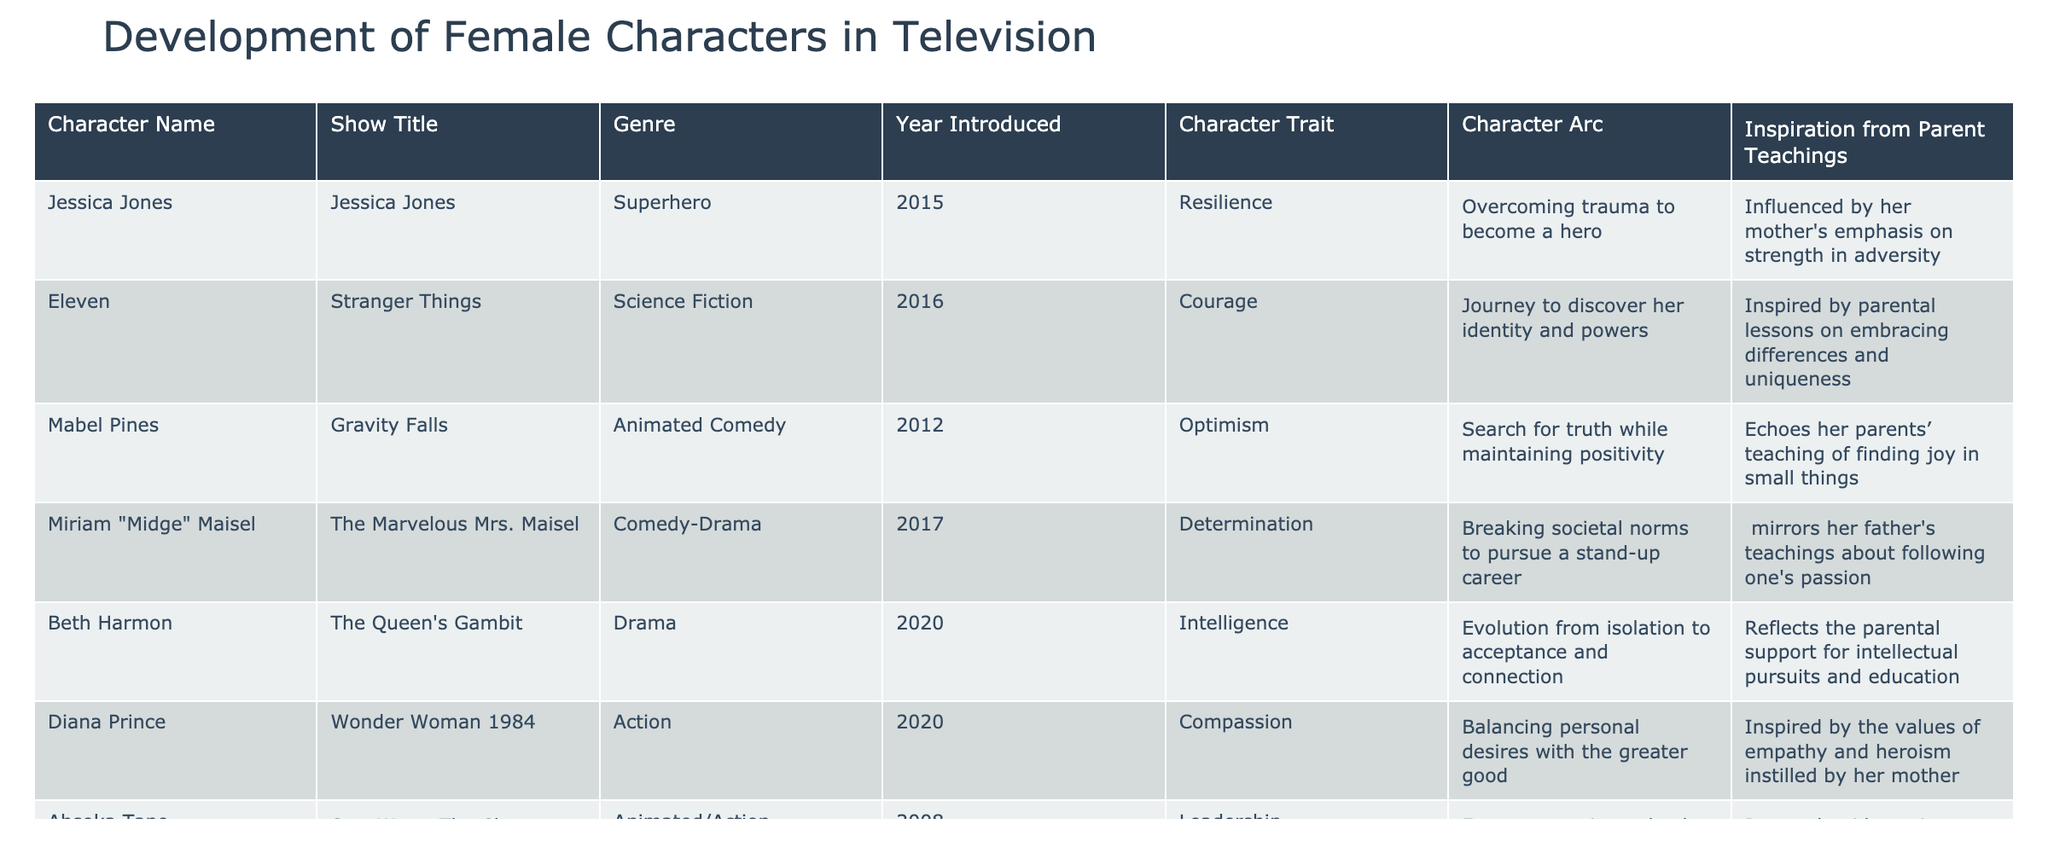What year was Jessica Jones introduced? Looking at the table, the row for Jessica Jones indicates that she was introduced in the year 2015.
Answer: 2015 Which character displays the trait of independence? By checking the character trait column, I can see that Samantha "Sam" Ponder is associated with independence.
Answer: Samantha "Sam" Ponder How many characters were introduced after 2015? The characters introduced after 2015 are Jessica Jones (2015), Eleven (2016), Miriam "Midge" Maisel (2017), Veronica Lodge (2017), and Samantha "Sam" Ponder (2017). This totals to 5 characters.
Answer: 5 Does Mabel Pines have a character arc related to optimism? In the table, the entry for Mabel Pines clearly indicates that her character trait is optimism, which means this statement is true.
Answer: Yes Which character has a character arc involving overcoming trauma? The character Jessica Jones from the show "Jessica Jones" has the character arc of overcoming trauma to become a hero, as stated in the table.
Answer: Jessica Jones Which female character's story reflects parental teachings about pursuing passions? Referring to the table, Miriam "Midge" Maisel reflects her father's teachings about following one's passion, as noted in the inspiration from parent teachings column.
Answer: Miriam "Midge" Maisel What is the character trait of Diana Prince? According to the table, Diana Prince's character trait is compassion, as mentioned in her row.
Answer: Compassion How many characters have a parental teaching related to strength and protection? Checking the inspirations, Jessica Jones and Michonne both have parental teachings related to strength and protection: Jessica relates to her mother's emphasis on strength in adversity, while Michonne is influenced by her father's messages of loyalty and protection. Thus, there are 2 characters.
Answer: 2 